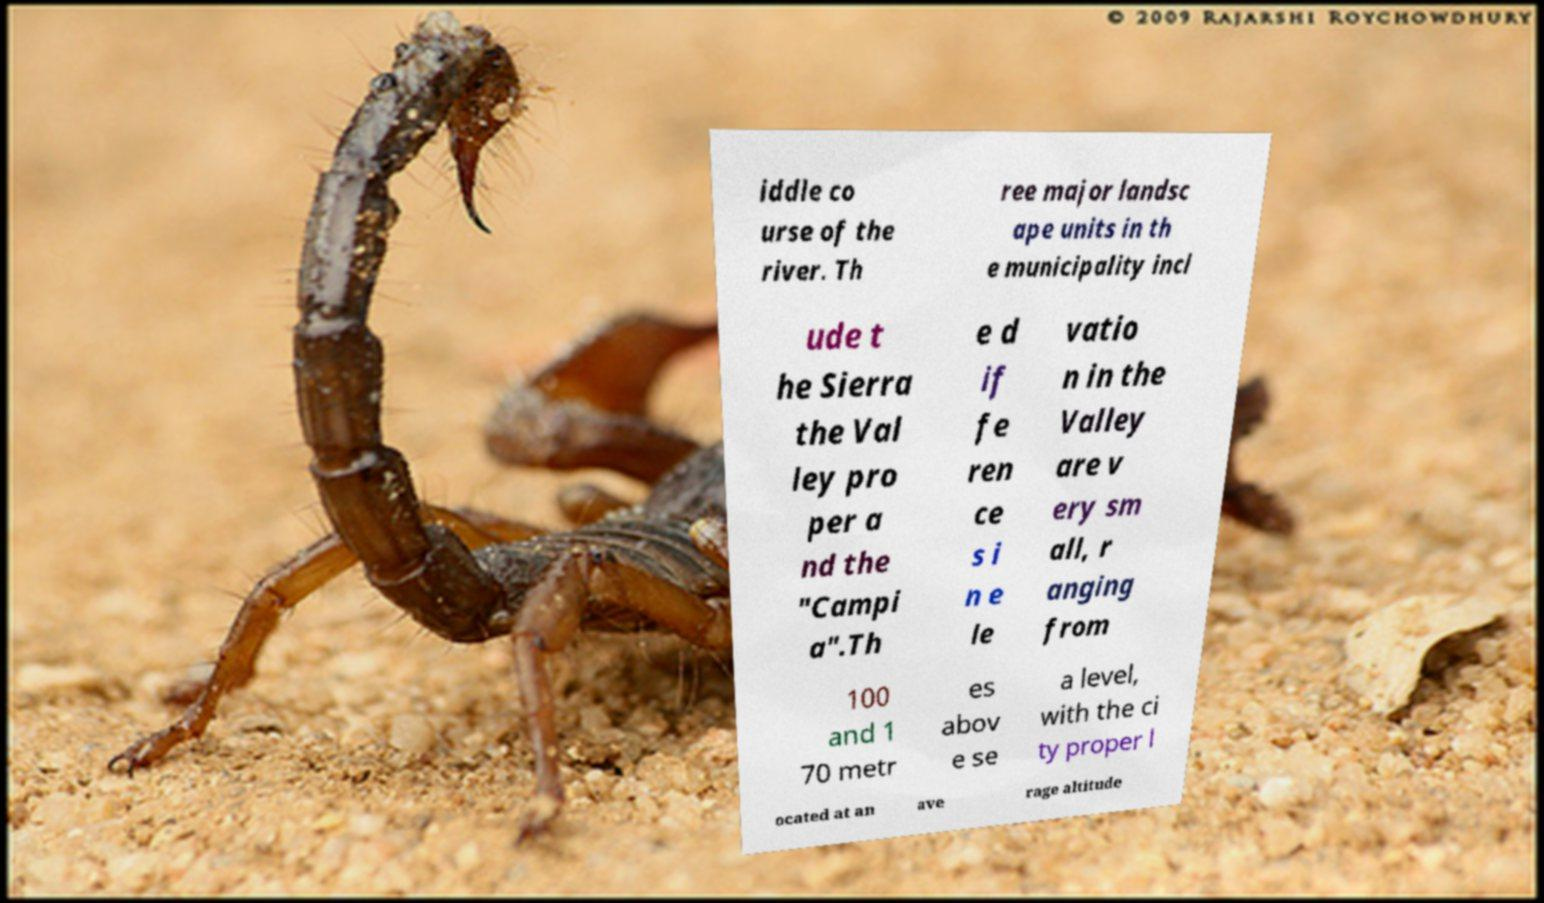What messages or text are displayed in this image? I need them in a readable, typed format. iddle co urse of the river. Th ree major landsc ape units in th e municipality incl ude t he Sierra the Val ley pro per a nd the "Campi a".Th e d if fe ren ce s i n e le vatio n in the Valley are v ery sm all, r anging from 100 and 1 70 metr es abov e se a level, with the ci ty proper l ocated at an ave rage altitude 